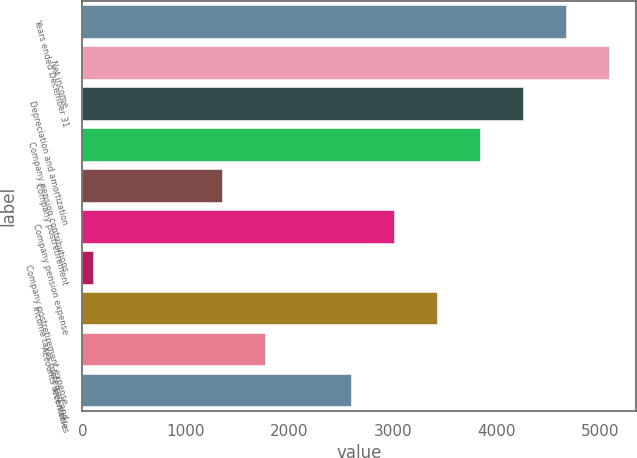<chart> <loc_0><loc_0><loc_500><loc_500><bar_chart><fcel>Years ended December 31<fcel>Net income<fcel>Depreciation and amortization<fcel>Company pension contributions<fcel>Company postretirement<fcel>Company pension expense<fcel>Company postretirement expense<fcel>Income taxes (deferred and<fcel>Accounts receivable<fcel>Inventories<nl><fcel>4673.2<fcel>5088.4<fcel>4258<fcel>3842.8<fcel>1351.6<fcel>3012.4<fcel>106<fcel>3427.6<fcel>1766.8<fcel>2597.2<nl></chart> 